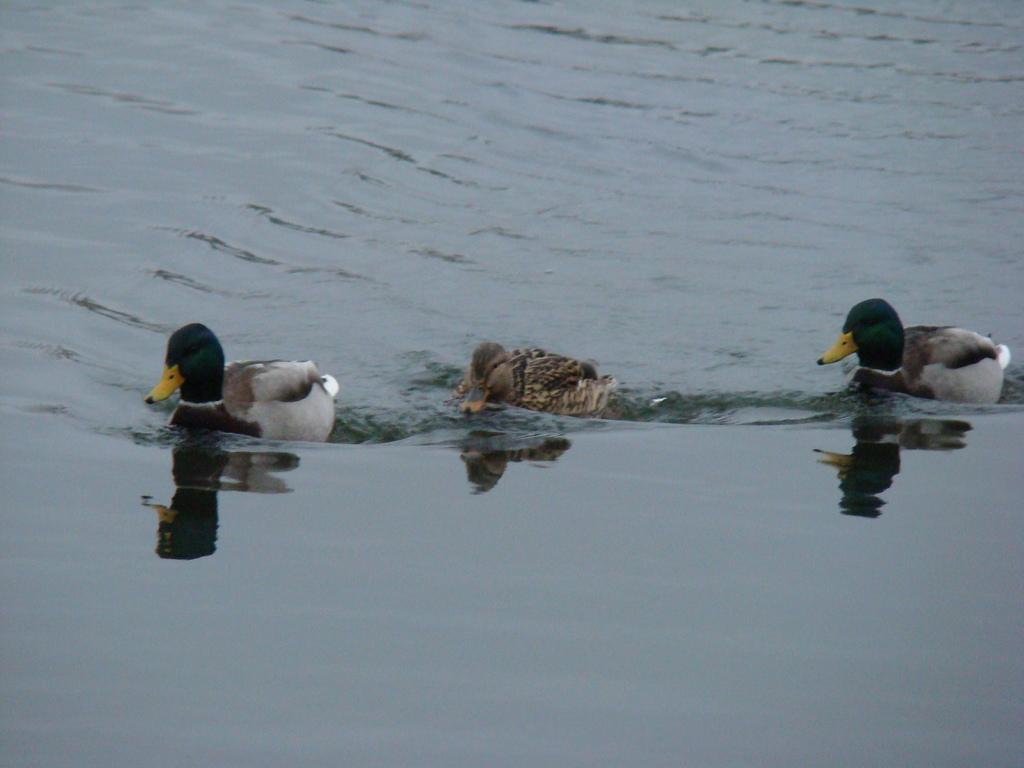How many ducks are present in the image? There are three ducks in the image. What are the ducks doing in the image? The ducks are moving in the water. What type of money can be seen in the image? There is no money present in the image; it features three ducks moving in the water. 